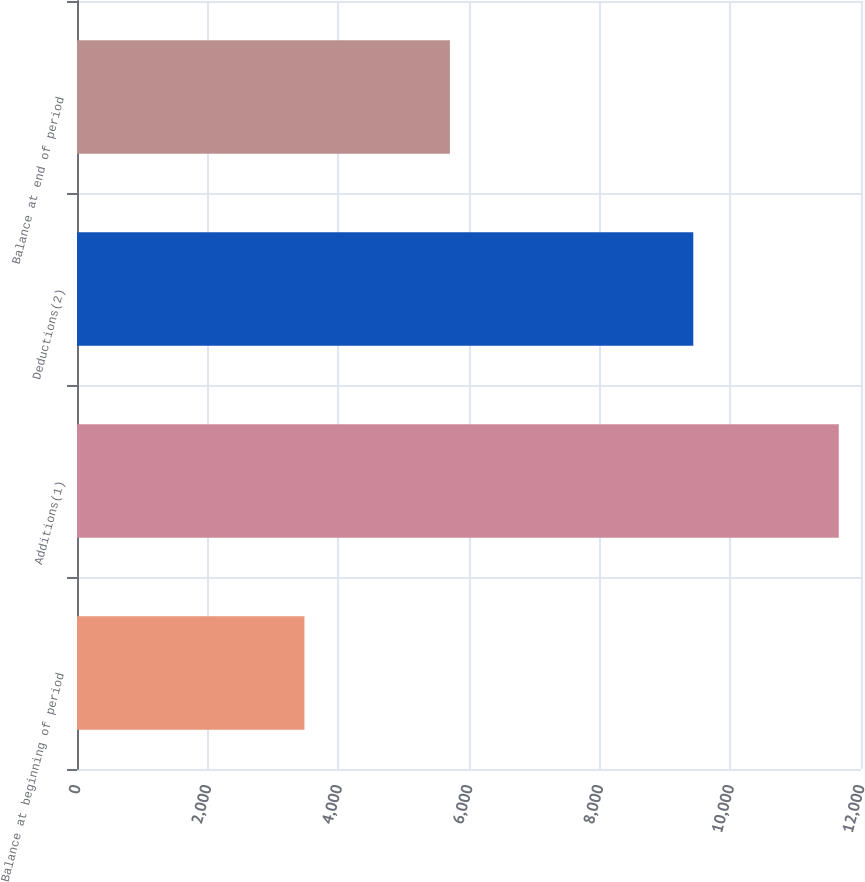Convert chart. <chart><loc_0><loc_0><loc_500><loc_500><bar_chart><fcel>Balance at beginning of period<fcel>Additions(1)<fcel>Deductions(2)<fcel>Balance at end of period<nl><fcel>3481<fcel>11660<fcel>9433<fcel>5708<nl></chart> 